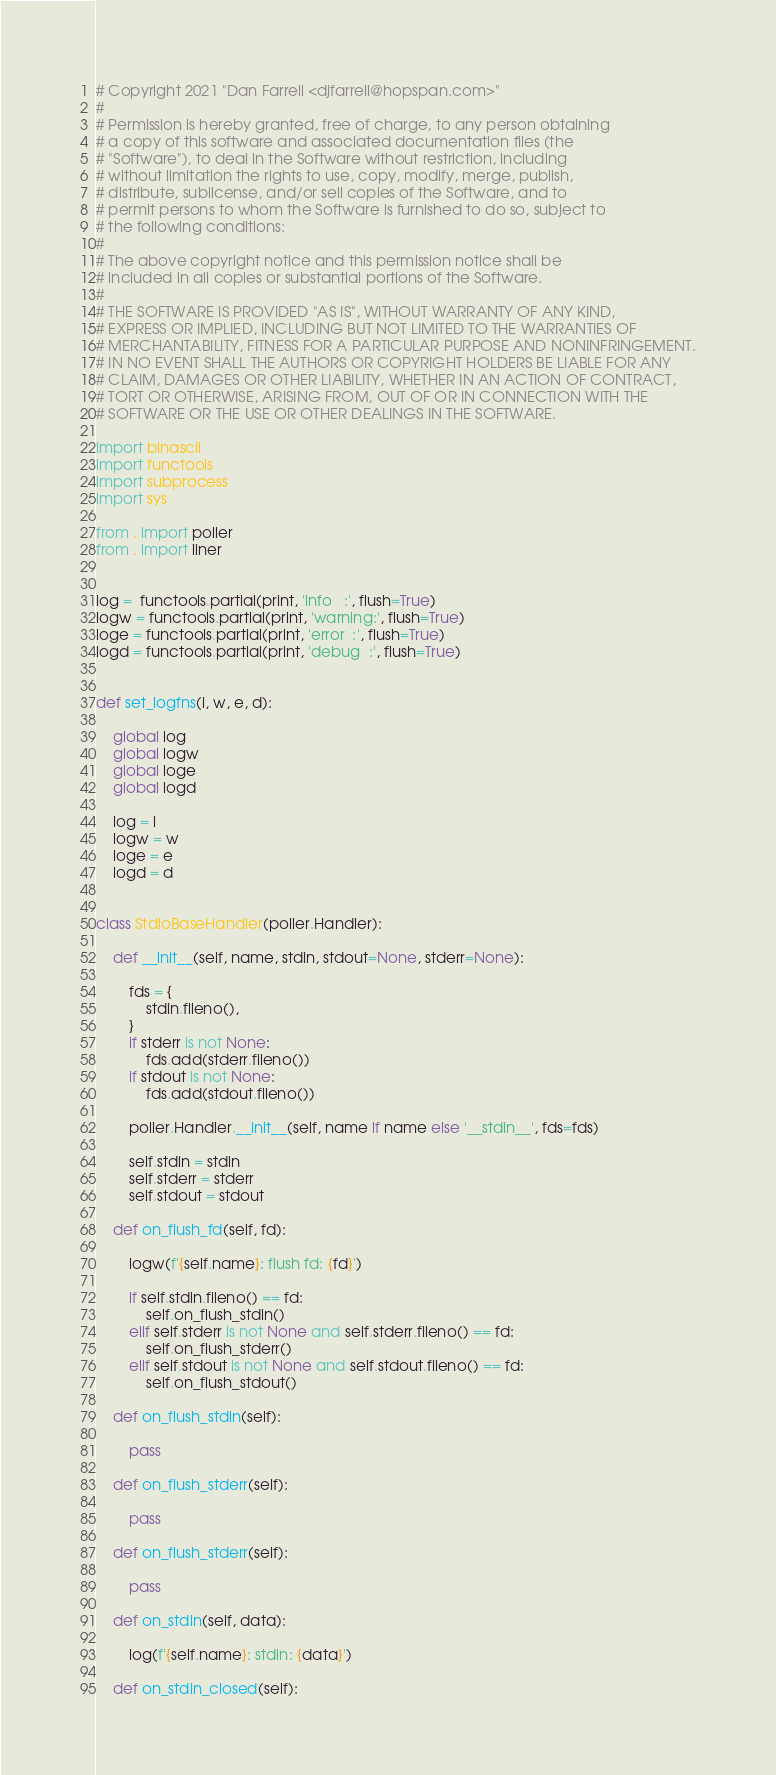<code> <loc_0><loc_0><loc_500><loc_500><_Python_># Copyright 2021 "Dan Farrell <djfarrell@hopspan.com>"
# 
# Permission is hereby granted, free of charge, to any person obtaining
# a copy of this software and associated documentation files (the
# "Software"), to deal in the Software without restriction, including
# without limitation the rights to use, copy, modify, merge, publish,
# distribute, sublicense, and/or sell copies of the Software, and to
# permit persons to whom the Software is furnished to do so, subject to
# the following conditions:
# 
# The above copyright notice and this permission notice shall be
# included in all copies or substantial portions of the Software.
# 
# THE SOFTWARE IS PROVIDED "AS IS", WITHOUT WARRANTY OF ANY KIND,
# EXPRESS OR IMPLIED, INCLUDING BUT NOT LIMITED TO THE WARRANTIES OF
# MERCHANTABILITY, FITNESS FOR A PARTICULAR PURPOSE AND NONINFRINGEMENT.
# IN NO EVENT SHALL THE AUTHORS OR COPYRIGHT HOLDERS BE LIABLE FOR ANY
# CLAIM, DAMAGES OR OTHER LIABILITY, WHETHER IN AN ACTION OF CONTRACT,
# TORT OR OTHERWISE, ARISING FROM, OUT OF OR IN CONNECTION WITH THE
# SOFTWARE OR THE USE OR OTHER DEALINGS IN THE SOFTWARE.

import binascii
import functools
import subprocess
import sys

from . import poller
from . import liner


log =  functools.partial(print, 'info   :', flush=True)
logw = functools.partial(print, 'warning:', flush=True)
loge = functools.partial(print, 'error  :', flush=True)
logd = functools.partial(print, 'debug  :', flush=True)


def set_logfns(i, w, e, d):

    global log
    global logw
    global loge
    global logd

    log = i
    logw = w
    loge = e
    logd = d


class StdioBaseHandler(poller.Handler):

    def __init__(self, name, stdin, stdout=None, stderr=None):

        fds = {
            stdin.fileno(),
        }
        if stderr is not None:
            fds.add(stderr.fileno())
        if stdout is not None:
            fds.add(stdout.fileno())

        poller.Handler.__init__(self, name if name else '__stdin__', fds=fds)

        self.stdin = stdin
        self.stderr = stderr
        self.stdout = stdout

    def on_flush_fd(self, fd):

        logw(f'{self.name}: flush fd: {fd}')

        if self.stdin.fileno() == fd:
            self.on_flush_stdin()
        elif self.stderr is not None and self.stderr.fileno() == fd:
            self.on_flush_stderr()
        elif self.stdout is not None and self.stdout.fileno() == fd:
            self.on_flush_stdout()

    def on_flush_stdin(self):

        pass

    def on_flush_stderr(self):

        pass

    def on_flush_stderr(self):

        pass

    def on_stdin(self, data):

        log(f'{self.name}: stdin: {data}')

    def on_stdin_closed(self):
</code> 